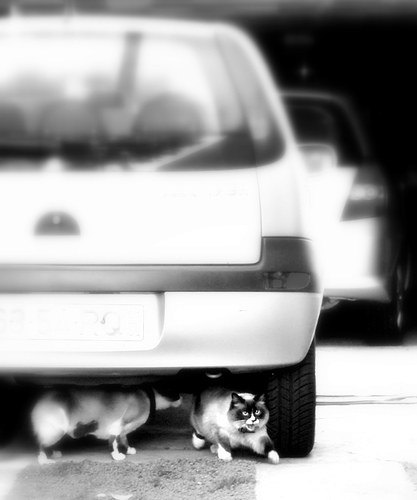How many cats are there? 2 